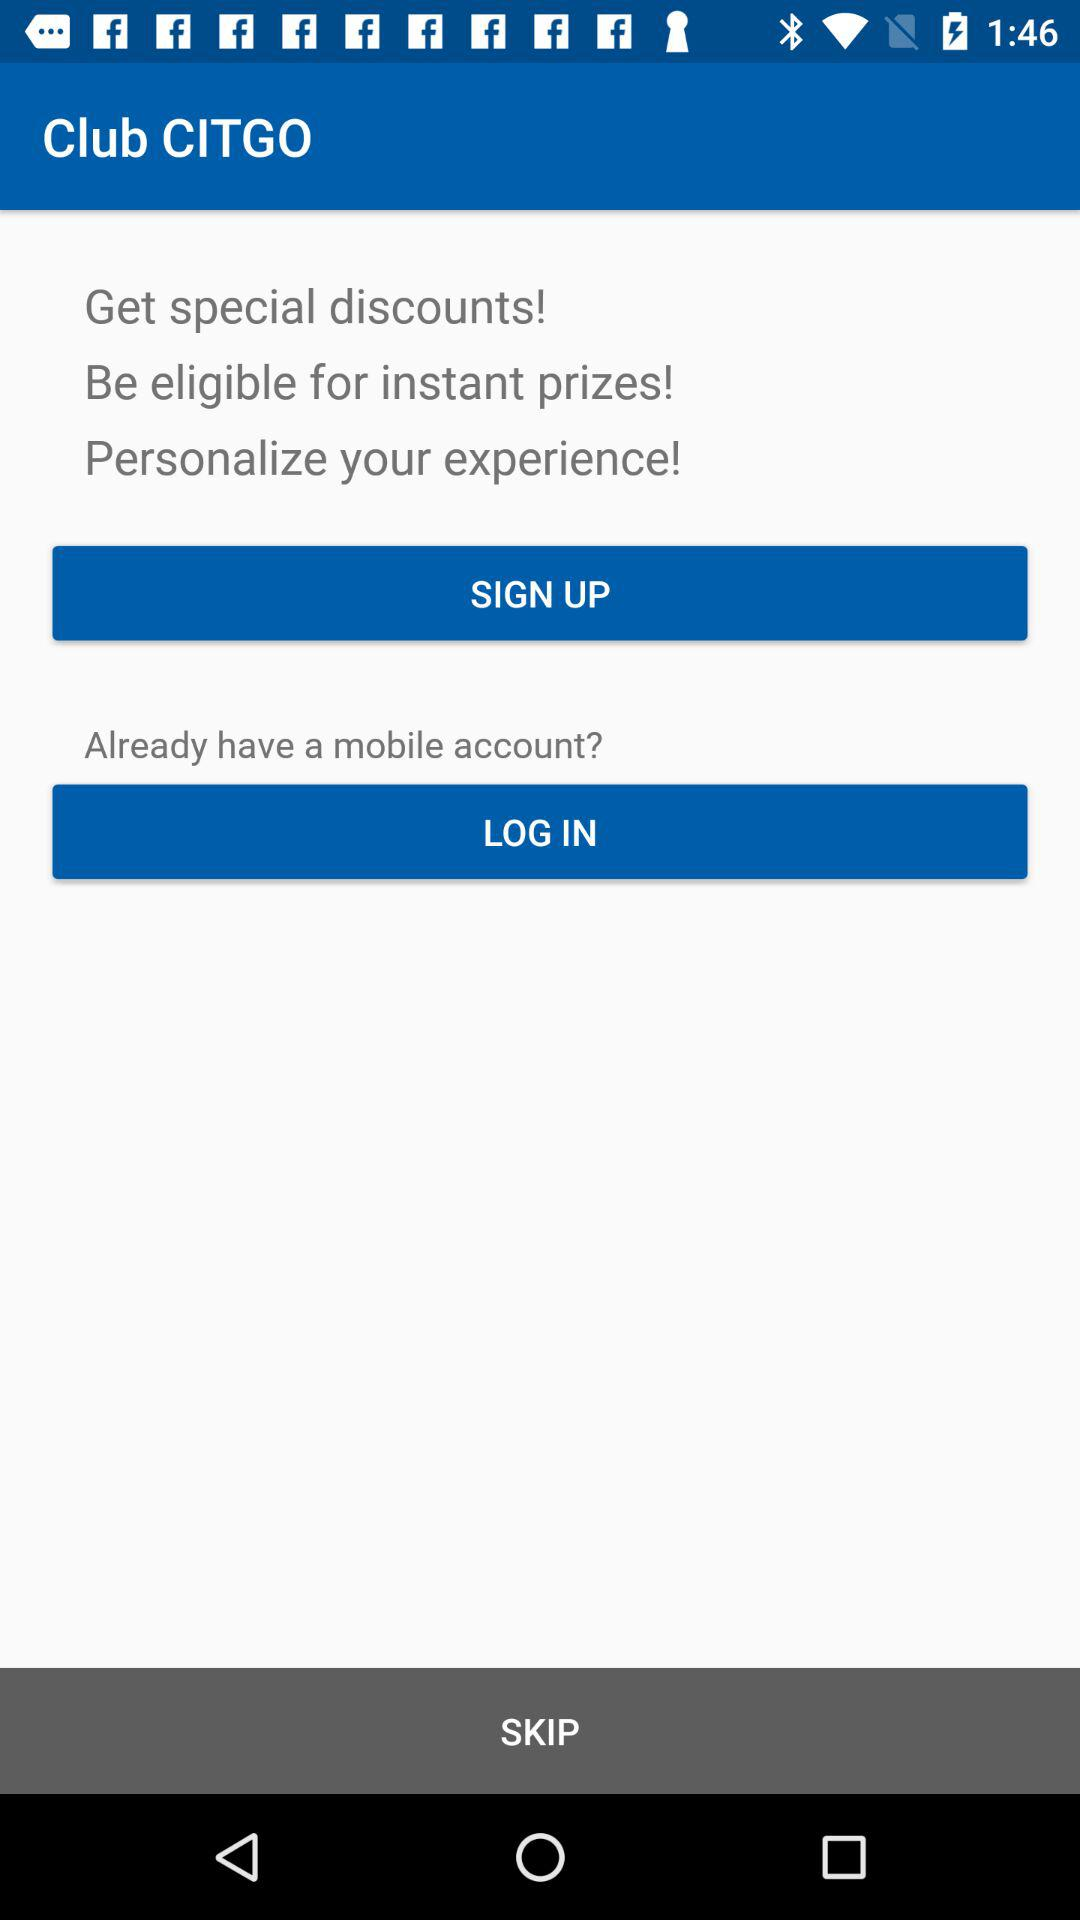What is the application name? The application name is "Club CITGO". 